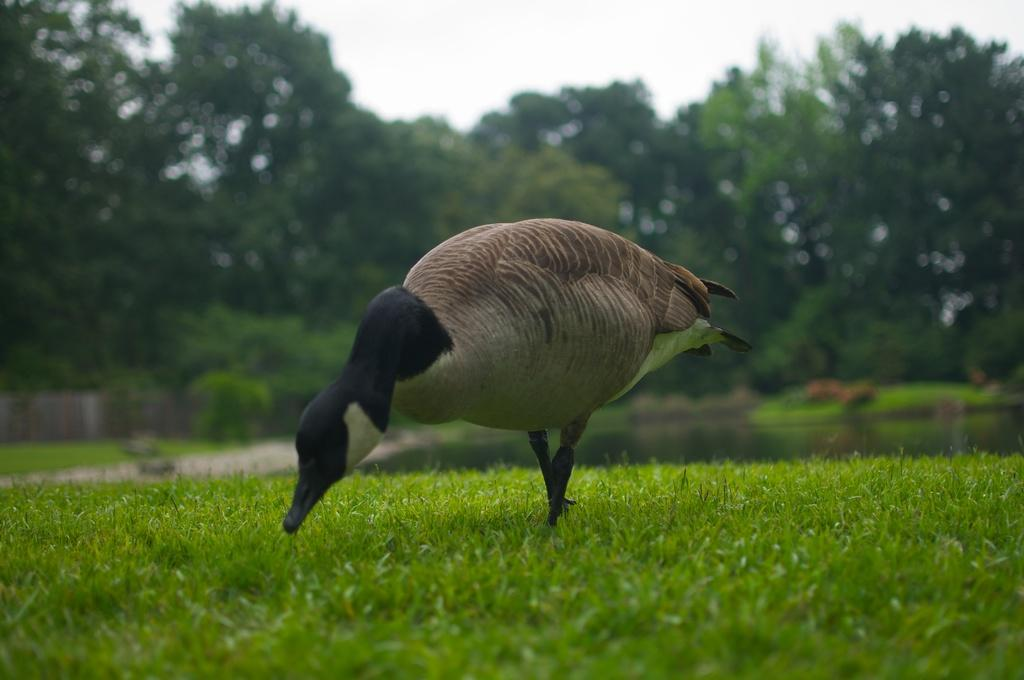What animal is the main subject of the picture? There is a turkey in the picture. What can be seen in the background of the picture? Trees are visible in the background of the picture. What is visible in the picture besides the turkey and trees? There is water and grass visible in the picture. What type of teeth does the turkey have in the picture? Turkeys do not have teeth, so there are no teeth visible in the picture. 